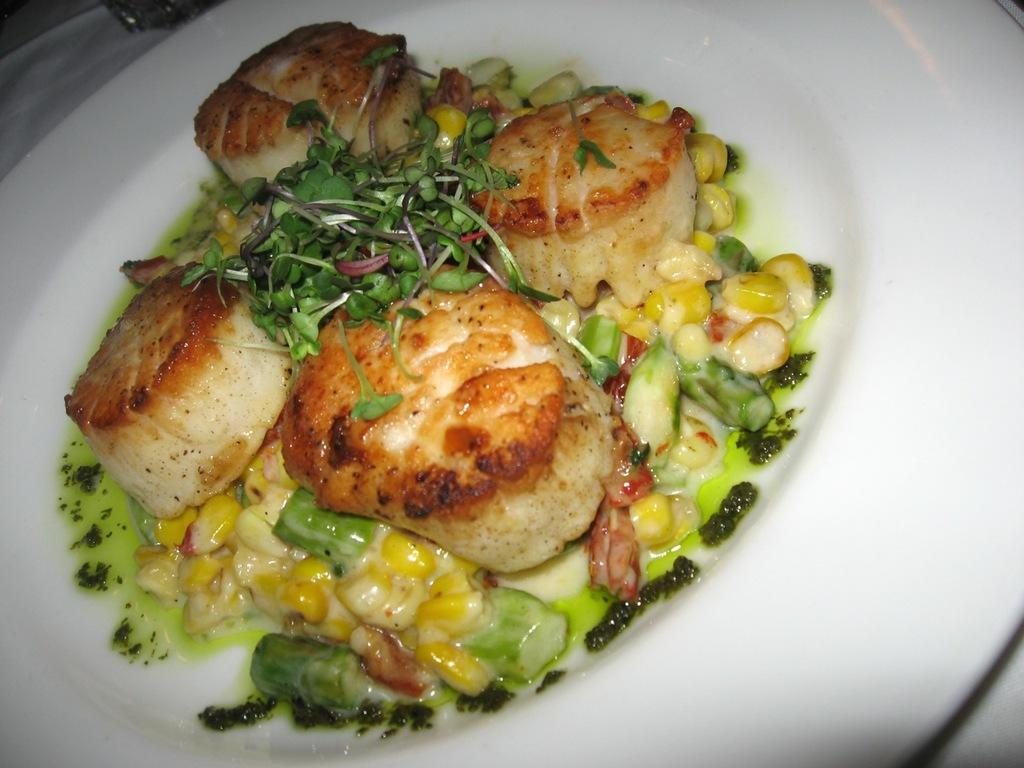What is the main subject of the image? There is a food item in the image. How is the food item presented in the image? The food item is placed on a white color plate. Where is the plate located in the image? The plate is located in the middle of the image. How many babies are present in the image? There are no babies present in the image; it features a food item on a plate. Does the existence of the food item prove the existence of a unit? The presence of the food item does not prove the existence of a unit, as the concept of a unit is not related to the image. 